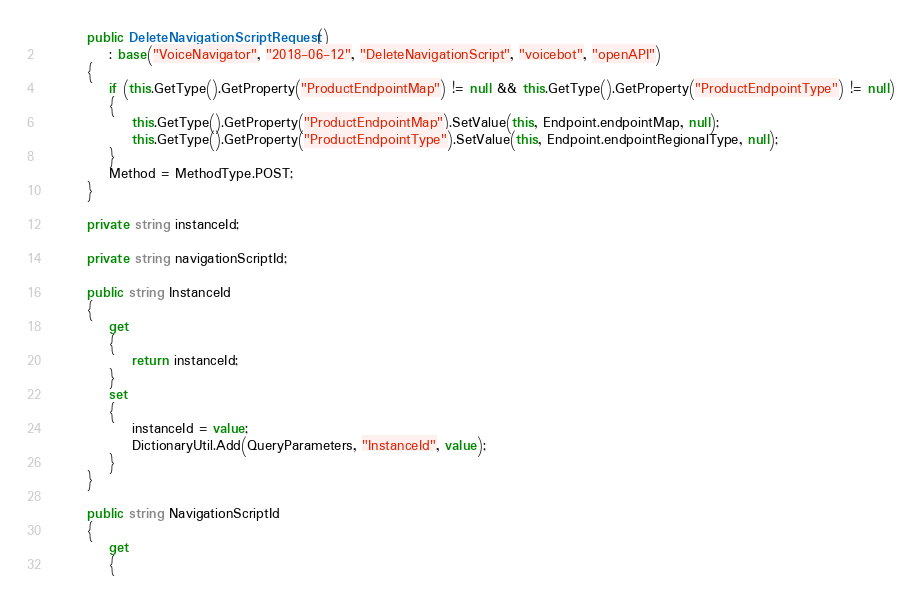Convert code to text. <code><loc_0><loc_0><loc_500><loc_500><_C#_>        public DeleteNavigationScriptRequest()
            : base("VoiceNavigator", "2018-06-12", "DeleteNavigationScript", "voicebot", "openAPI")
        {
            if (this.GetType().GetProperty("ProductEndpointMap") != null && this.GetType().GetProperty("ProductEndpointType") != null)
            {
                this.GetType().GetProperty("ProductEndpointMap").SetValue(this, Endpoint.endpointMap, null);
                this.GetType().GetProperty("ProductEndpointType").SetValue(this, Endpoint.endpointRegionalType, null);
            }
			Method = MethodType.POST;
        }

		private string instanceId;

		private string navigationScriptId;

		public string InstanceId
		{
			get
			{
				return instanceId;
			}
			set	
			{
				instanceId = value;
				DictionaryUtil.Add(QueryParameters, "InstanceId", value);
			}
		}

		public string NavigationScriptId
		{
			get
			{</code> 